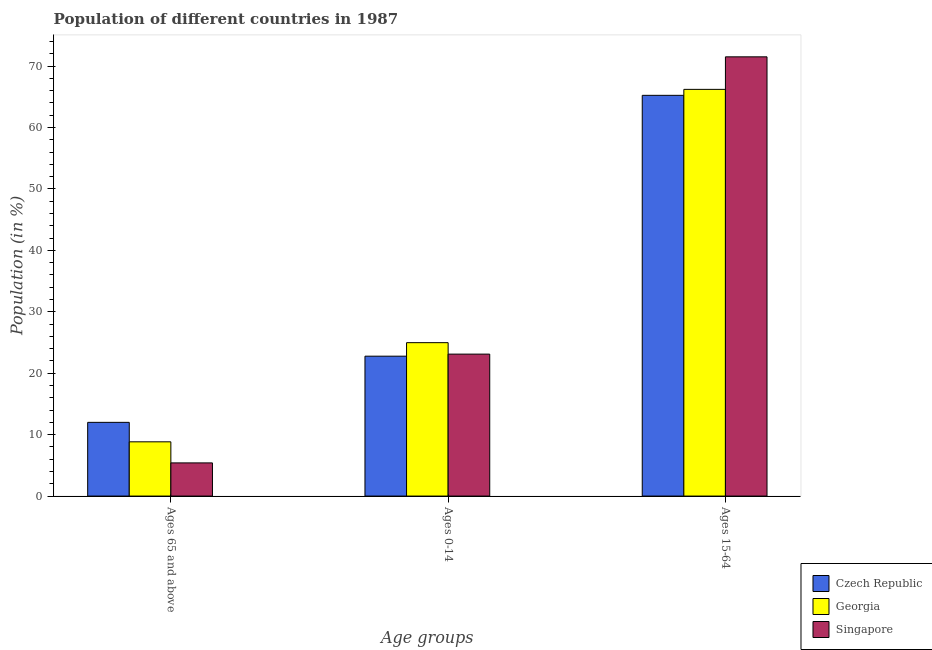How many different coloured bars are there?
Keep it short and to the point. 3. How many groups of bars are there?
Your response must be concise. 3. Are the number of bars per tick equal to the number of legend labels?
Offer a very short reply. Yes. Are the number of bars on each tick of the X-axis equal?
Your answer should be very brief. Yes. How many bars are there on the 1st tick from the right?
Provide a succinct answer. 3. What is the label of the 2nd group of bars from the left?
Keep it short and to the point. Ages 0-14. What is the percentage of population within the age-group 15-64 in Singapore?
Provide a short and direct response. 71.5. Across all countries, what is the maximum percentage of population within the age-group of 65 and above?
Keep it short and to the point. 12. Across all countries, what is the minimum percentage of population within the age-group of 65 and above?
Offer a very short reply. 5.4. In which country was the percentage of population within the age-group 0-14 maximum?
Ensure brevity in your answer.  Georgia. In which country was the percentage of population within the age-group of 65 and above minimum?
Offer a very short reply. Singapore. What is the total percentage of population within the age-group 0-14 in the graph?
Make the answer very short. 70.85. What is the difference between the percentage of population within the age-group of 65 and above in Georgia and that in Czech Republic?
Offer a terse response. -3.17. What is the difference between the percentage of population within the age-group 0-14 in Czech Republic and the percentage of population within the age-group 15-64 in Georgia?
Ensure brevity in your answer.  -43.43. What is the average percentage of population within the age-group 15-64 per country?
Your response must be concise. 67.64. What is the difference between the percentage of population within the age-group 0-14 and percentage of population within the age-group 15-64 in Georgia?
Make the answer very short. -41.23. In how many countries, is the percentage of population within the age-group 15-64 greater than 2 %?
Ensure brevity in your answer.  3. What is the ratio of the percentage of population within the age-group 15-64 in Singapore to that in Georgia?
Give a very brief answer. 1.08. Is the difference between the percentage of population within the age-group of 65 and above in Singapore and Georgia greater than the difference between the percentage of population within the age-group 0-14 in Singapore and Georgia?
Make the answer very short. No. What is the difference between the highest and the second highest percentage of population within the age-group of 65 and above?
Ensure brevity in your answer.  3.17. What is the difference between the highest and the lowest percentage of population within the age-group 15-64?
Give a very brief answer. 6.27. Is the sum of the percentage of population within the age-group of 65 and above in Singapore and Czech Republic greater than the maximum percentage of population within the age-group 0-14 across all countries?
Give a very brief answer. No. What does the 2nd bar from the left in Ages 65 and above represents?
Provide a short and direct response. Georgia. What does the 3rd bar from the right in Ages 15-64 represents?
Give a very brief answer. Czech Republic. Is it the case that in every country, the sum of the percentage of population within the age-group of 65 and above and percentage of population within the age-group 0-14 is greater than the percentage of population within the age-group 15-64?
Offer a terse response. No. What is the difference between two consecutive major ticks on the Y-axis?
Make the answer very short. 10. Does the graph contain grids?
Your answer should be compact. No. How are the legend labels stacked?
Ensure brevity in your answer.  Vertical. What is the title of the graph?
Make the answer very short. Population of different countries in 1987. What is the label or title of the X-axis?
Your answer should be very brief. Age groups. What is the label or title of the Y-axis?
Give a very brief answer. Population (in %). What is the Population (in %) of Czech Republic in Ages 65 and above?
Your response must be concise. 12. What is the Population (in %) in Georgia in Ages 65 and above?
Keep it short and to the point. 8.83. What is the Population (in %) in Singapore in Ages 65 and above?
Provide a succinct answer. 5.4. What is the Population (in %) of Czech Republic in Ages 0-14?
Your response must be concise. 22.77. What is the Population (in %) of Georgia in Ages 0-14?
Your answer should be very brief. 24.97. What is the Population (in %) in Singapore in Ages 0-14?
Ensure brevity in your answer.  23.11. What is the Population (in %) in Czech Republic in Ages 15-64?
Offer a terse response. 65.23. What is the Population (in %) of Georgia in Ages 15-64?
Keep it short and to the point. 66.2. What is the Population (in %) of Singapore in Ages 15-64?
Keep it short and to the point. 71.5. Across all Age groups, what is the maximum Population (in %) of Czech Republic?
Ensure brevity in your answer.  65.23. Across all Age groups, what is the maximum Population (in %) of Georgia?
Offer a terse response. 66.2. Across all Age groups, what is the maximum Population (in %) of Singapore?
Make the answer very short. 71.5. Across all Age groups, what is the minimum Population (in %) in Czech Republic?
Offer a terse response. 12. Across all Age groups, what is the minimum Population (in %) of Georgia?
Ensure brevity in your answer.  8.83. Across all Age groups, what is the minimum Population (in %) of Singapore?
Give a very brief answer. 5.4. What is the total Population (in %) in Singapore in the graph?
Provide a short and direct response. 100. What is the difference between the Population (in %) of Czech Republic in Ages 65 and above and that in Ages 0-14?
Give a very brief answer. -10.77. What is the difference between the Population (in %) in Georgia in Ages 65 and above and that in Ages 0-14?
Your response must be concise. -16.14. What is the difference between the Population (in %) in Singapore in Ages 65 and above and that in Ages 0-14?
Your answer should be very brief. -17.71. What is the difference between the Population (in %) of Czech Republic in Ages 65 and above and that in Ages 15-64?
Give a very brief answer. -53.23. What is the difference between the Population (in %) in Georgia in Ages 65 and above and that in Ages 15-64?
Give a very brief answer. -57.37. What is the difference between the Population (in %) in Singapore in Ages 65 and above and that in Ages 15-64?
Give a very brief answer. -66.1. What is the difference between the Population (in %) in Czech Republic in Ages 0-14 and that in Ages 15-64?
Your response must be concise. -42.46. What is the difference between the Population (in %) in Georgia in Ages 0-14 and that in Ages 15-64?
Give a very brief answer. -41.23. What is the difference between the Population (in %) in Singapore in Ages 0-14 and that in Ages 15-64?
Your answer should be compact. -48.39. What is the difference between the Population (in %) in Czech Republic in Ages 65 and above and the Population (in %) in Georgia in Ages 0-14?
Give a very brief answer. -12.97. What is the difference between the Population (in %) of Czech Republic in Ages 65 and above and the Population (in %) of Singapore in Ages 0-14?
Your answer should be compact. -11.11. What is the difference between the Population (in %) of Georgia in Ages 65 and above and the Population (in %) of Singapore in Ages 0-14?
Ensure brevity in your answer.  -14.28. What is the difference between the Population (in %) in Czech Republic in Ages 65 and above and the Population (in %) in Georgia in Ages 15-64?
Provide a succinct answer. -54.2. What is the difference between the Population (in %) in Czech Republic in Ages 65 and above and the Population (in %) in Singapore in Ages 15-64?
Provide a succinct answer. -59.5. What is the difference between the Population (in %) of Georgia in Ages 65 and above and the Population (in %) of Singapore in Ages 15-64?
Your response must be concise. -62.66. What is the difference between the Population (in %) of Czech Republic in Ages 0-14 and the Population (in %) of Georgia in Ages 15-64?
Provide a succinct answer. -43.43. What is the difference between the Population (in %) in Czech Republic in Ages 0-14 and the Population (in %) in Singapore in Ages 15-64?
Keep it short and to the point. -48.72. What is the difference between the Population (in %) in Georgia in Ages 0-14 and the Population (in %) in Singapore in Ages 15-64?
Give a very brief answer. -46.53. What is the average Population (in %) in Czech Republic per Age groups?
Your answer should be compact. 33.33. What is the average Population (in %) in Georgia per Age groups?
Offer a terse response. 33.33. What is the average Population (in %) in Singapore per Age groups?
Give a very brief answer. 33.33. What is the difference between the Population (in %) in Czech Republic and Population (in %) in Georgia in Ages 65 and above?
Make the answer very short. 3.17. What is the difference between the Population (in %) in Czech Republic and Population (in %) in Singapore in Ages 65 and above?
Offer a terse response. 6.6. What is the difference between the Population (in %) in Georgia and Population (in %) in Singapore in Ages 65 and above?
Provide a succinct answer. 3.43. What is the difference between the Population (in %) in Czech Republic and Population (in %) in Georgia in Ages 0-14?
Offer a terse response. -2.2. What is the difference between the Population (in %) of Czech Republic and Population (in %) of Singapore in Ages 0-14?
Your answer should be compact. -0.34. What is the difference between the Population (in %) in Georgia and Population (in %) in Singapore in Ages 0-14?
Provide a succinct answer. 1.86. What is the difference between the Population (in %) in Czech Republic and Population (in %) in Georgia in Ages 15-64?
Provide a succinct answer. -0.97. What is the difference between the Population (in %) of Czech Republic and Population (in %) of Singapore in Ages 15-64?
Provide a short and direct response. -6.27. What is the difference between the Population (in %) in Georgia and Population (in %) in Singapore in Ages 15-64?
Provide a short and direct response. -5.3. What is the ratio of the Population (in %) of Czech Republic in Ages 65 and above to that in Ages 0-14?
Offer a very short reply. 0.53. What is the ratio of the Population (in %) of Georgia in Ages 65 and above to that in Ages 0-14?
Your answer should be very brief. 0.35. What is the ratio of the Population (in %) of Singapore in Ages 65 and above to that in Ages 0-14?
Your answer should be compact. 0.23. What is the ratio of the Population (in %) of Czech Republic in Ages 65 and above to that in Ages 15-64?
Make the answer very short. 0.18. What is the ratio of the Population (in %) of Georgia in Ages 65 and above to that in Ages 15-64?
Keep it short and to the point. 0.13. What is the ratio of the Population (in %) in Singapore in Ages 65 and above to that in Ages 15-64?
Provide a short and direct response. 0.08. What is the ratio of the Population (in %) of Czech Republic in Ages 0-14 to that in Ages 15-64?
Your answer should be compact. 0.35. What is the ratio of the Population (in %) in Georgia in Ages 0-14 to that in Ages 15-64?
Your answer should be very brief. 0.38. What is the ratio of the Population (in %) of Singapore in Ages 0-14 to that in Ages 15-64?
Provide a short and direct response. 0.32. What is the difference between the highest and the second highest Population (in %) of Czech Republic?
Your response must be concise. 42.46. What is the difference between the highest and the second highest Population (in %) in Georgia?
Your answer should be compact. 41.23. What is the difference between the highest and the second highest Population (in %) of Singapore?
Your answer should be very brief. 48.39. What is the difference between the highest and the lowest Population (in %) in Czech Republic?
Offer a terse response. 53.23. What is the difference between the highest and the lowest Population (in %) of Georgia?
Your answer should be compact. 57.37. What is the difference between the highest and the lowest Population (in %) of Singapore?
Keep it short and to the point. 66.1. 